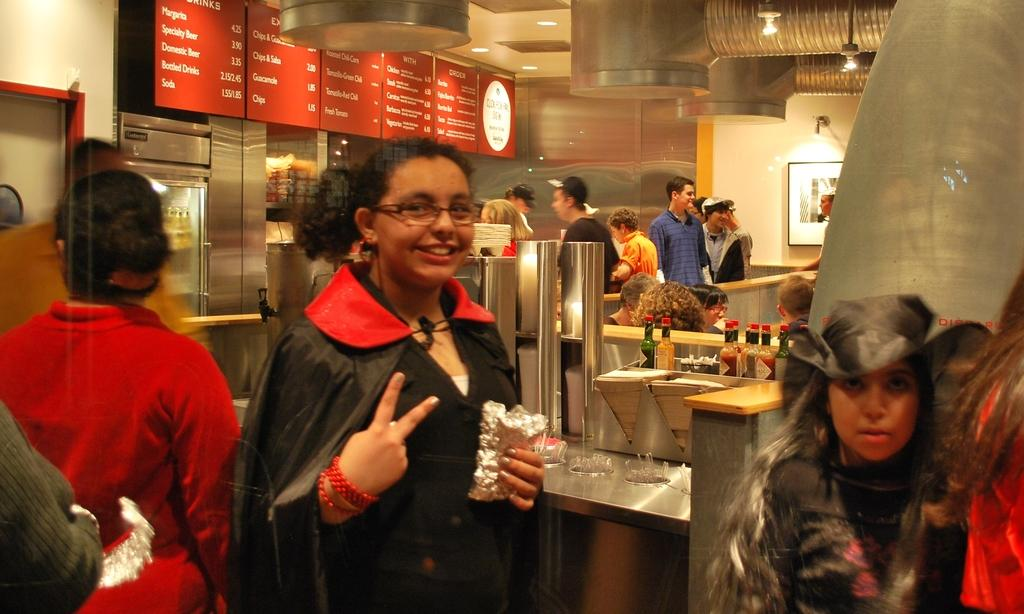How many people can be seen in the image? There are people in the image, but the exact number is not specified. What type of furniture is present in the image? There are tables in the image. What objects are related to beverages or drinks? There are bottles in the image. What appliances can be seen in the image? There are refrigerators in the image. What type of surface is used for displaying information or messages? There are boards in the image. What type of structure separates the space? There is a wall in the image. What type of decorative or functional object is present in the image? There is a frame in the image. What type of illumination is present in the image? There are lights in the image. What type of overhead structure is present in the image? There is a ceiling in the image. Can you tell me the story behind the jelly on the table in the image? There is no mention of jelly in the image, so it is not possible to provide a story about it. How old is the boy sitting at the table in the image? There is no boy present in the image, so it is not possible to determine his age. 